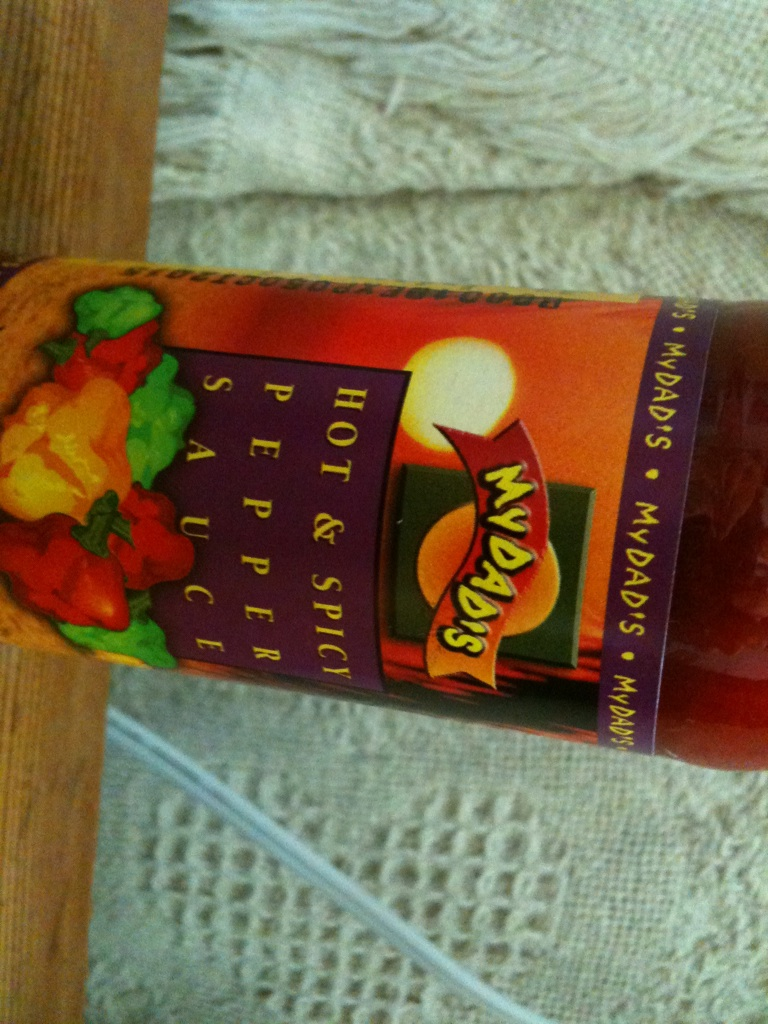What would be a realistic scenario for using this pepper sauce in a short response? A realistic use for this pepper sauce could be adding it to a homemade chili for an additional kick of heat and depth of flavor.  Describe another realistic scenario in a more detailed response. Consider using this pepper sauce as a marinade base for a weekend barbecue. Marinate a selection of meats, like chicken thighs and shrimp, in a mixture of the pepper sauce with some honey, soy sauce, minced garlic, and a touch of lime juice. Let the flavors meld together for a few hours, then grill the meats to perfection. The pepper sauce adds a delicious heat that caramelizes beautifully with the honey on the grill, creating a mouth-watering glaze that's sure to impress your guests. 